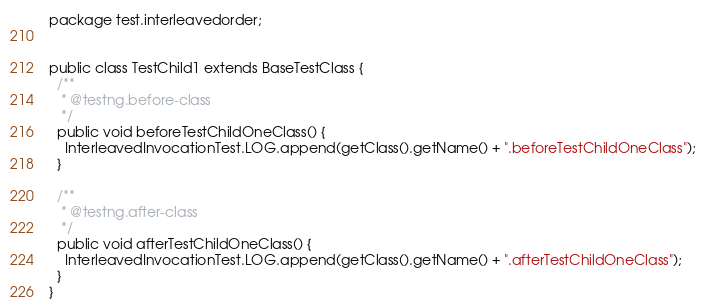<code> <loc_0><loc_0><loc_500><loc_500><_Java_>package test.interleavedorder;


public class TestChild1 extends BaseTestClass {
  /**
   * @testng.before-class
   */
  public void beforeTestChildOneClass() {
    InterleavedInvocationTest.LOG.append(getClass().getName() + ".beforeTestChildOneClass");
  }
  
  /**
   * @testng.after-class
   */
  public void afterTestChildOneClass() {
    InterleavedInvocationTest.LOG.append(getClass().getName() + ".afterTestChildOneClass");
  }
}
</code> 